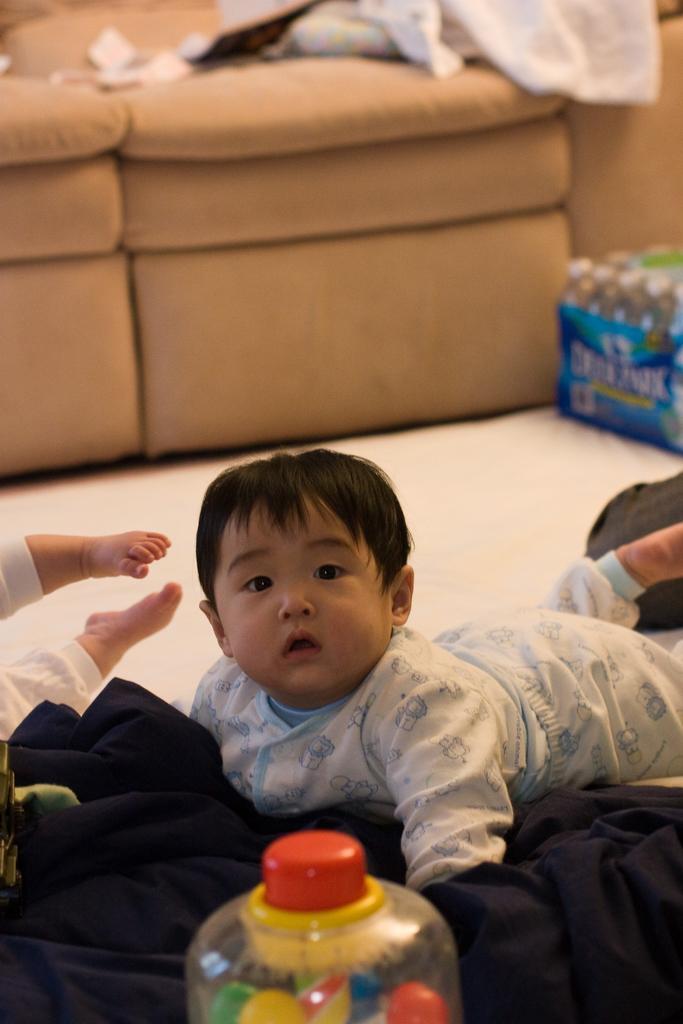How would you summarize this image in a sentence or two? In this picture I can see a sofa in the back and I can see a pack of water bottles and I can see a kid lying and I can see another kid on the left side and I can see a carpet on the floor and few clothes and I can see a toy at the bottom of the picture. 